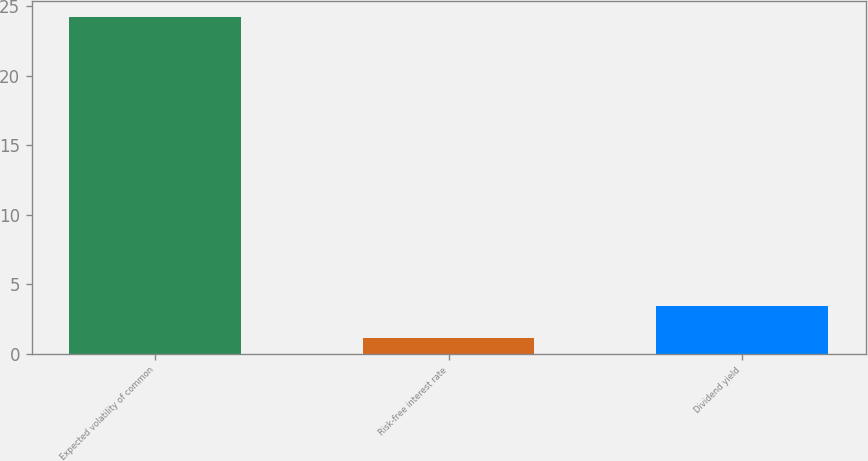Convert chart to OTSL. <chart><loc_0><loc_0><loc_500><loc_500><bar_chart><fcel>Expected volatility of common<fcel>Risk-free interest rate<fcel>Dividend yield<nl><fcel>24.2<fcel>1.1<fcel>3.41<nl></chart> 